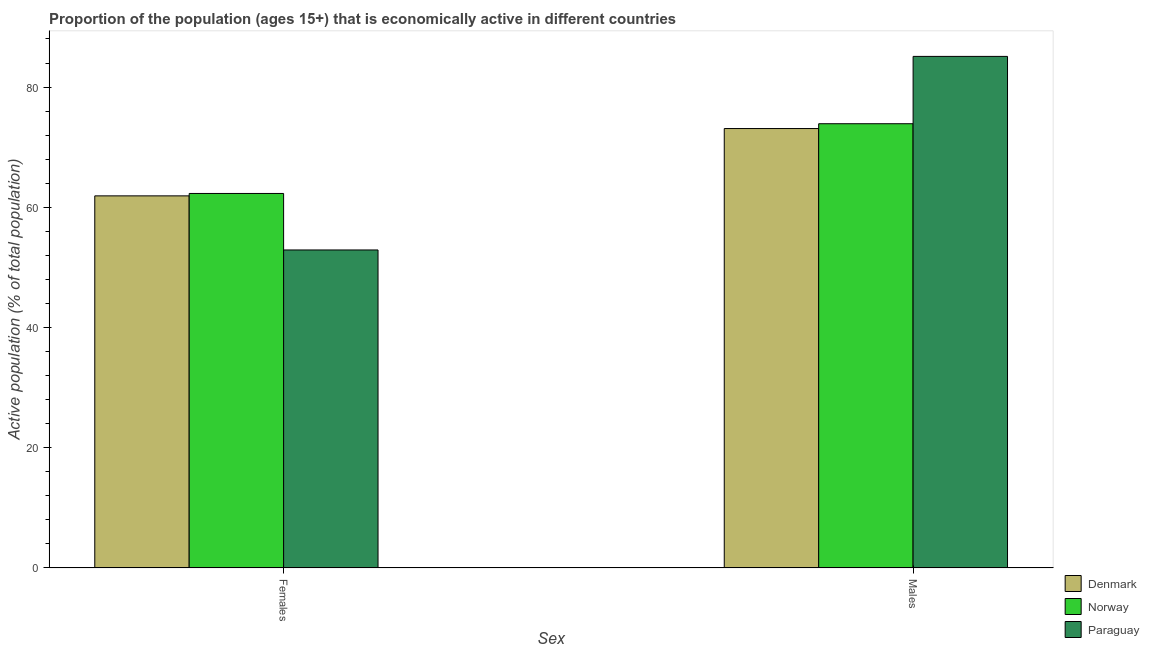How many different coloured bars are there?
Provide a short and direct response. 3. Are the number of bars per tick equal to the number of legend labels?
Give a very brief answer. Yes. Are the number of bars on each tick of the X-axis equal?
Your answer should be very brief. Yes. How many bars are there on the 2nd tick from the left?
Provide a succinct answer. 3. How many bars are there on the 1st tick from the right?
Give a very brief answer. 3. What is the label of the 2nd group of bars from the left?
Give a very brief answer. Males. What is the percentage of economically active female population in Norway?
Your answer should be compact. 62.3. Across all countries, what is the maximum percentage of economically active female population?
Offer a terse response. 62.3. Across all countries, what is the minimum percentage of economically active female population?
Provide a succinct answer. 52.9. In which country was the percentage of economically active male population maximum?
Your answer should be compact. Paraguay. In which country was the percentage of economically active female population minimum?
Give a very brief answer. Paraguay. What is the total percentage of economically active male population in the graph?
Provide a succinct answer. 232.1. What is the difference between the percentage of economically active male population in Norway and that in Paraguay?
Provide a short and direct response. -11.2. What is the difference between the percentage of economically active female population in Denmark and the percentage of economically active male population in Paraguay?
Your response must be concise. -23.2. What is the average percentage of economically active male population per country?
Offer a very short reply. 77.37. What is the difference between the percentage of economically active male population and percentage of economically active female population in Norway?
Your answer should be compact. 11.6. What is the ratio of the percentage of economically active male population in Paraguay to that in Norway?
Make the answer very short. 1.15. Is the percentage of economically active male population in Denmark less than that in Norway?
Your answer should be very brief. Yes. In how many countries, is the percentage of economically active female population greater than the average percentage of economically active female population taken over all countries?
Offer a very short reply. 2. What does the 3rd bar from the left in Females represents?
Your answer should be very brief. Paraguay. What does the 1st bar from the right in Females represents?
Make the answer very short. Paraguay. Are all the bars in the graph horizontal?
Keep it short and to the point. No. Are the values on the major ticks of Y-axis written in scientific E-notation?
Your answer should be compact. No. How many legend labels are there?
Give a very brief answer. 3. What is the title of the graph?
Give a very brief answer. Proportion of the population (ages 15+) that is economically active in different countries. Does "France" appear as one of the legend labels in the graph?
Give a very brief answer. No. What is the label or title of the X-axis?
Offer a terse response. Sex. What is the label or title of the Y-axis?
Your response must be concise. Active population (% of total population). What is the Active population (% of total population) of Denmark in Females?
Provide a short and direct response. 61.9. What is the Active population (% of total population) in Norway in Females?
Your answer should be very brief. 62.3. What is the Active population (% of total population) of Paraguay in Females?
Your response must be concise. 52.9. What is the Active population (% of total population) of Denmark in Males?
Provide a succinct answer. 73.1. What is the Active population (% of total population) in Norway in Males?
Provide a succinct answer. 73.9. What is the Active population (% of total population) of Paraguay in Males?
Your response must be concise. 85.1. Across all Sex, what is the maximum Active population (% of total population) in Denmark?
Your response must be concise. 73.1. Across all Sex, what is the maximum Active population (% of total population) in Norway?
Keep it short and to the point. 73.9. Across all Sex, what is the maximum Active population (% of total population) in Paraguay?
Make the answer very short. 85.1. Across all Sex, what is the minimum Active population (% of total population) of Denmark?
Make the answer very short. 61.9. Across all Sex, what is the minimum Active population (% of total population) in Norway?
Offer a very short reply. 62.3. Across all Sex, what is the minimum Active population (% of total population) in Paraguay?
Provide a short and direct response. 52.9. What is the total Active population (% of total population) of Denmark in the graph?
Your answer should be compact. 135. What is the total Active population (% of total population) of Norway in the graph?
Keep it short and to the point. 136.2. What is the total Active population (% of total population) of Paraguay in the graph?
Make the answer very short. 138. What is the difference between the Active population (% of total population) of Denmark in Females and that in Males?
Ensure brevity in your answer.  -11.2. What is the difference between the Active population (% of total population) in Norway in Females and that in Males?
Make the answer very short. -11.6. What is the difference between the Active population (% of total population) in Paraguay in Females and that in Males?
Give a very brief answer. -32.2. What is the difference between the Active population (% of total population) of Denmark in Females and the Active population (% of total population) of Paraguay in Males?
Provide a succinct answer. -23.2. What is the difference between the Active population (% of total population) of Norway in Females and the Active population (% of total population) of Paraguay in Males?
Your answer should be compact. -22.8. What is the average Active population (% of total population) of Denmark per Sex?
Your response must be concise. 67.5. What is the average Active population (% of total population) in Norway per Sex?
Keep it short and to the point. 68.1. What is the difference between the Active population (% of total population) in Norway and Active population (% of total population) in Paraguay in Females?
Provide a short and direct response. 9.4. What is the ratio of the Active population (% of total population) in Denmark in Females to that in Males?
Ensure brevity in your answer.  0.85. What is the ratio of the Active population (% of total population) in Norway in Females to that in Males?
Offer a very short reply. 0.84. What is the ratio of the Active population (% of total population) of Paraguay in Females to that in Males?
Keep it short and to the point. 0.62. What is the difference between the highest and the second highest Active population (% of total population) in Denmark?
Offer a terse response. 11.2. What is the difference between the highest and the second highest Active population (% of total population) of Norway?
Ensure brevity in your answer.  11.6. What is the difference between the highest and the second highest Active population (% of total population) of Paraguay?
Make the answer very short. 32.2. What is the difference between the highest and the lowest Active population (% of total population) of Denmark?
Provide a short and direct response. 11.2. What is the difference between the highest and the lowest Active population (% of total population) of Norway?
Your answer should be compact. 11.6. What is the difference between the highest and the lowest Active population (% of total population) in Paraguay?
Your answer should be compact. 32.2. 